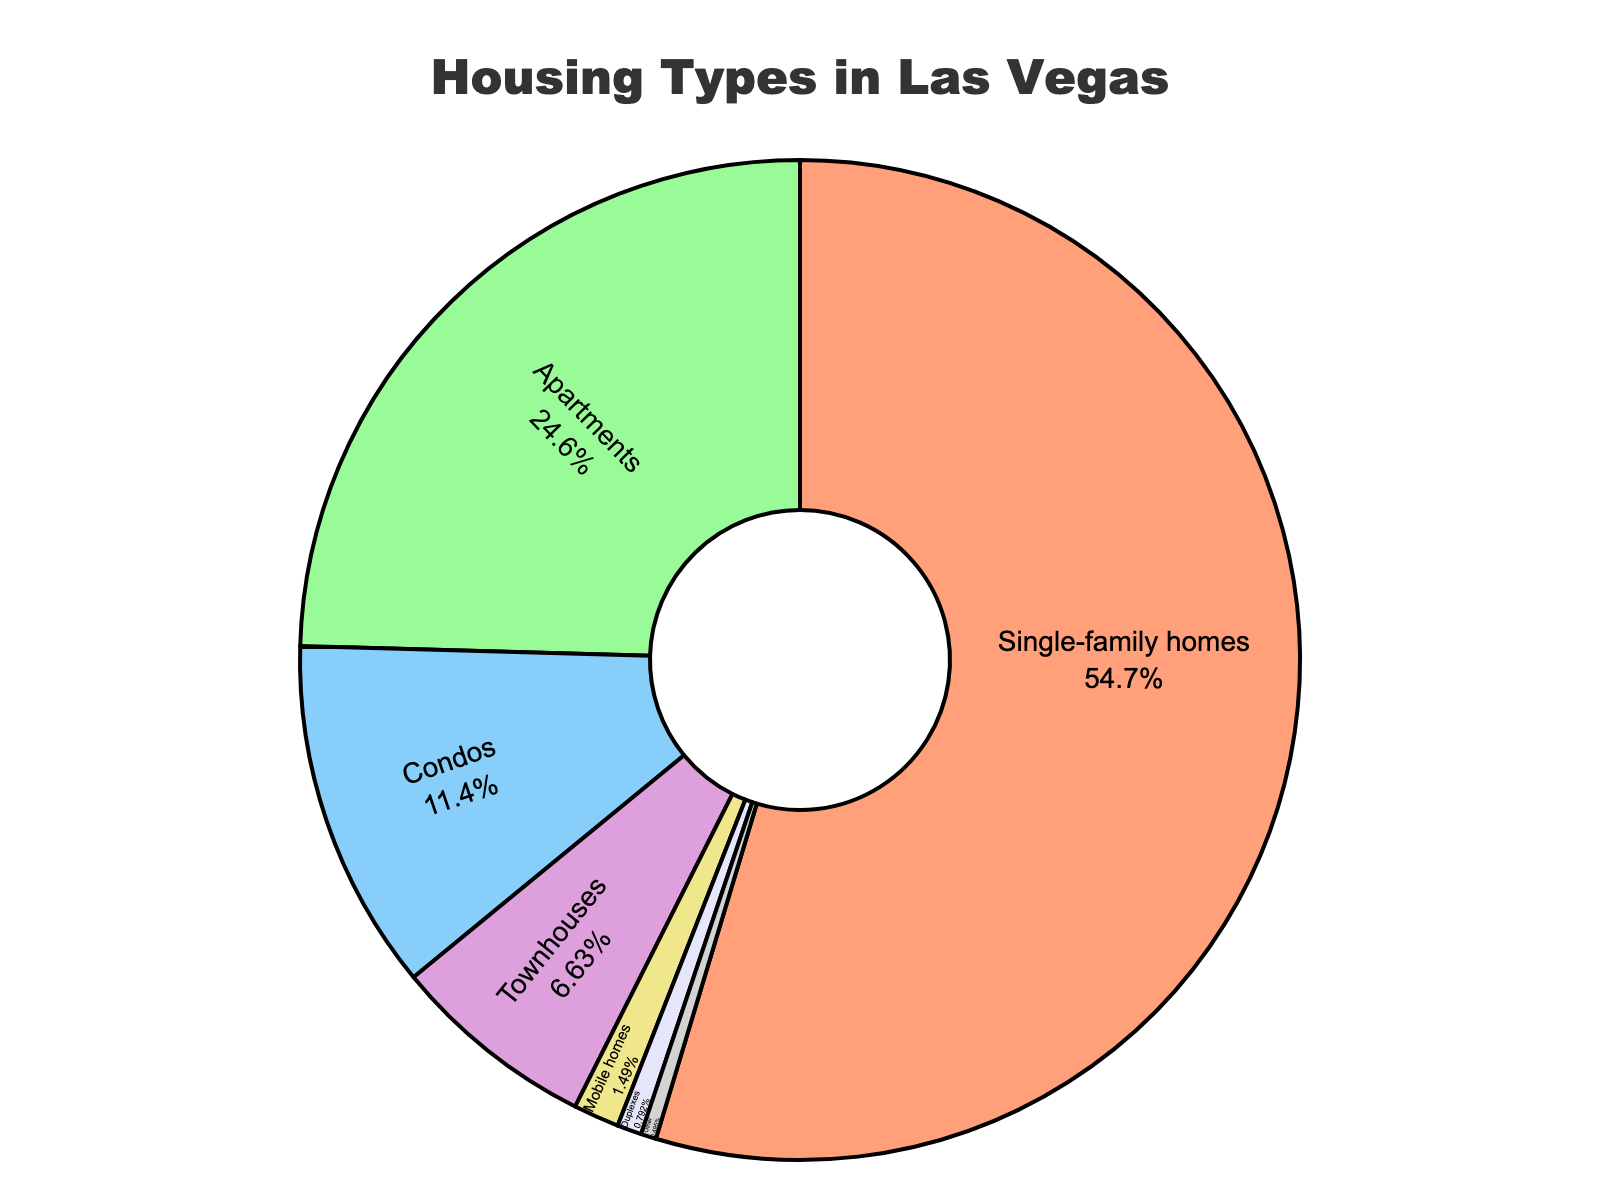What's the most common housing type in Las Vegas? Look at the segments on the pie chart and identify the one with the largest percentage. The largest segment represents 55.2% which corresponds to single-family homes.
Answer: Single-family homes What's the least common housing type in Las Vegas? Look at the segments on the pie chart and identify the one with the smallest percentage. The smallest segment is 0.5%, which corresponds to "Other".
Answer: Other How does the percentage of condos compare to the percentage of townhouses? Identify both segments and their respective percentages. The condos segment is 11.5% and the townhouses segment is 6.7%.
Answer: Condos are higher What is the combined percentage of single-family homes and apartments? Add the percentages of single-family homes (55.2%) and apartments (24.8%). 55.2 + 24.8 = 80%
Answer: 80% What housing type represents just over one-tenth of the market? Look for the segment close to 10%. Condos make up 11.5% of the market, which is just over one-tenth.
Answer: Condos If you combine duplexes and mobile homes, how does their total percentage compare to townhouses? Add the percentages for duplexes (0.8%) and mobile homes (1.5%) and compare to townhouses (6.7%). 0.8 + 1.5 = 2.3%, which is less than 6.7%.
Answer: Less than townhouses Which housing types make up more than 20% of the market? Identify the segments with more than 20%. Single-family homes (55.2%) and apartments (24.8%) are the only segments over 20%.
Answer: Single-family homes and apartments What is the visual color of the segment representing apartments in the pie chart? Look at the pie chart and identify the color corresponding to the apartments segment. The apartments segment is colored in green.
Answer: Green How many housing types each constitute less than 10% of the market? Count the segments representing less than 10%. Townhouses (6.7%), mobile homes (1.5%), duplexes (0.8%), and other (0.5%) each constitute less than 10%. There are 4 such segments.
Answer: 4 What is the difference in percentage between single-family homes and the second most common type of housing? Subtract the percentage of the second most common type (apartments at 24.8%) from single-family homes (55.2%). 55.2 - 24.8 = 30.4%
Answer: 30.4% 